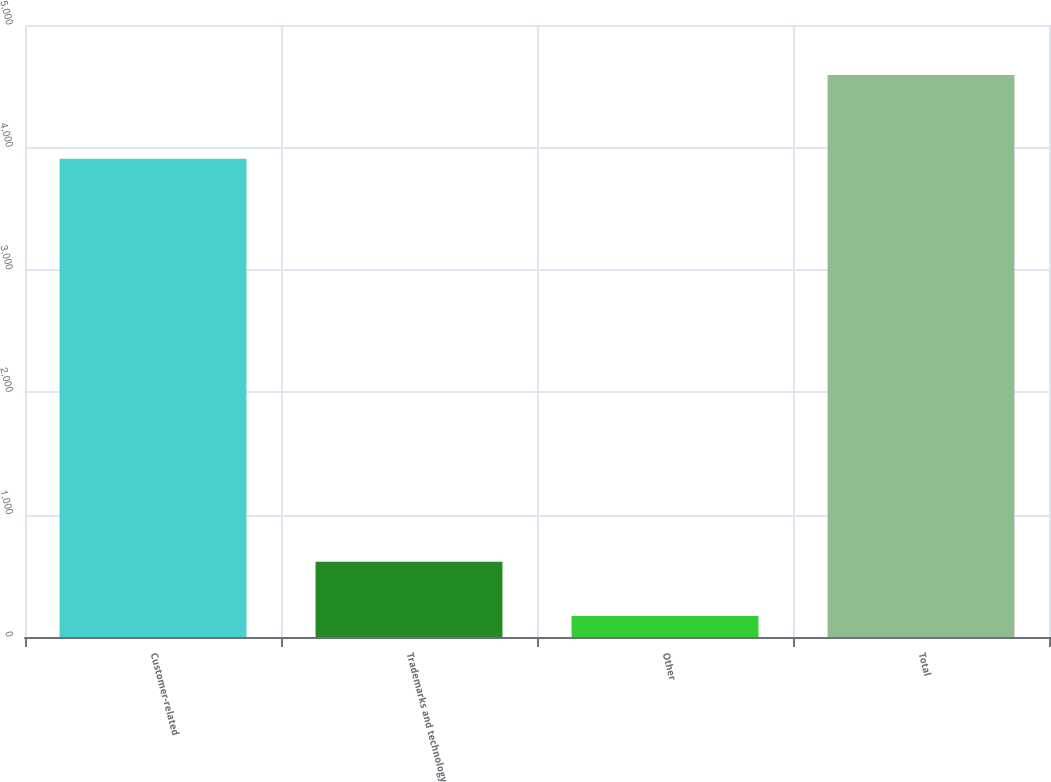Convert chart to OTSL. <chart><loc_0><loc_0><loc_500><loc_500><bar_chart><fcel>Customer-related<fcel>Trademarks and technology<fcel>Other<fcel>Total<nl><fcel>3908<fcel>614<fcel>172<fcel>4592<nl></chart> 